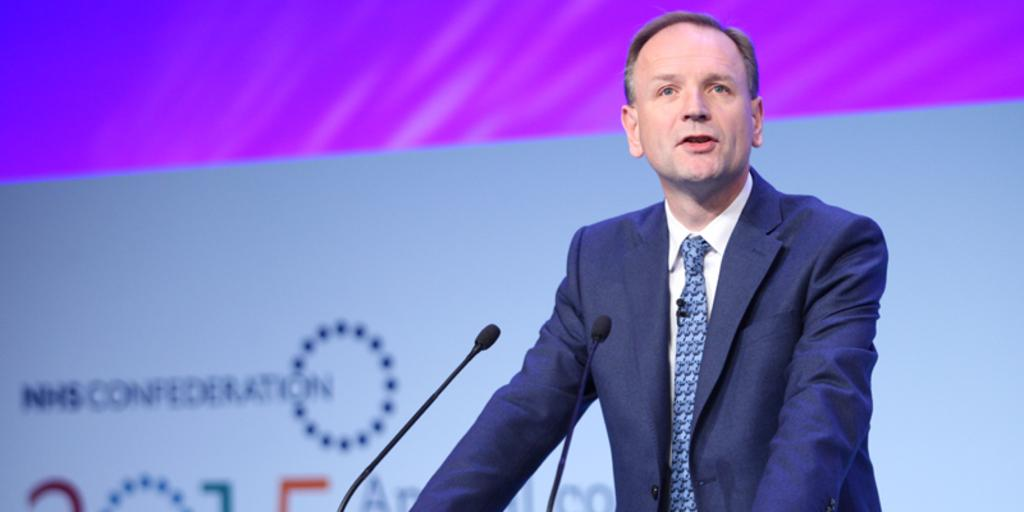What is the person in the image doing? The person is standing and talking in the image. What object is present that might be used for amplifying the person's voice? There is a microphone (mic) in the image. What can be seen in the background of the image? There is a banner with text in the background of the image. Is there a bomb visible in the image? No, there is no bomb present in the image. Can you see a cow in the background of the image? No, there is no cow present in the image. 